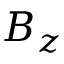<formula> <loc_0><loc_0><loc_500><loc_500>B _ { z }</formula> 